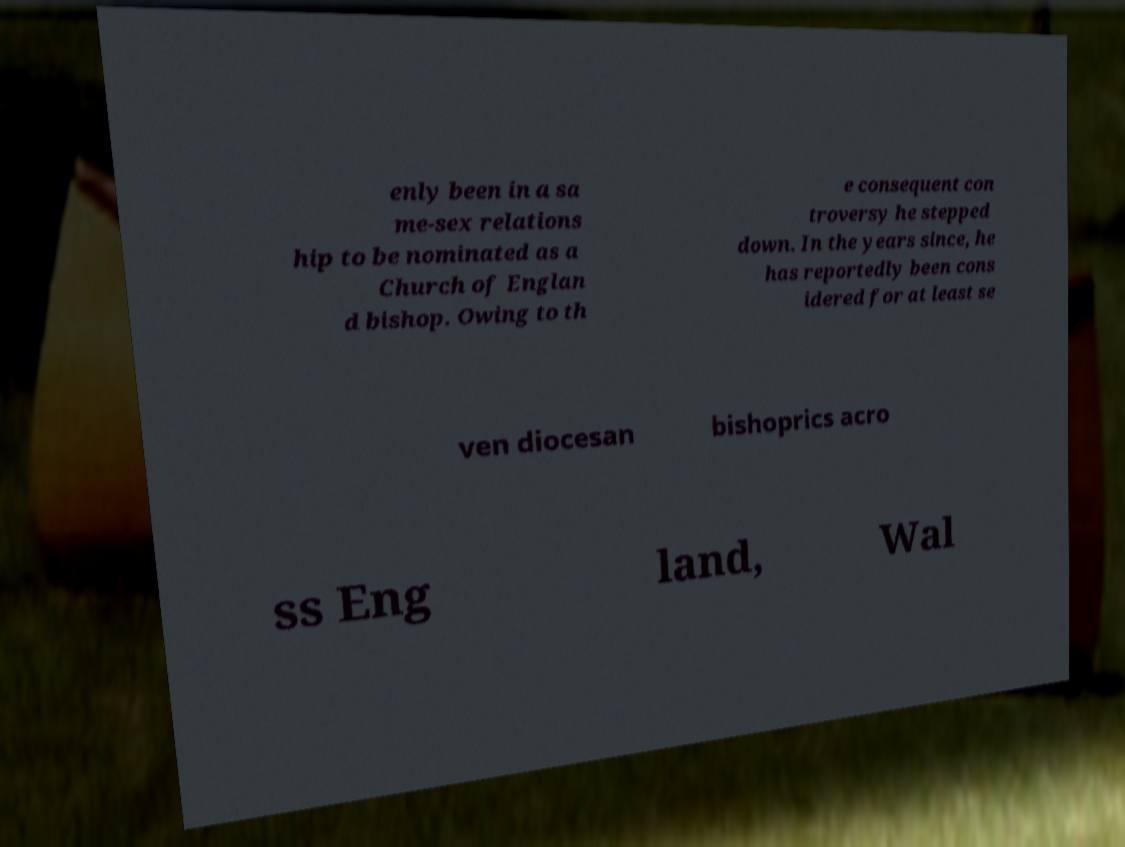Could you assist in decoding the text presented in this image and type it out clearly? enly been in a sa me-sex relations hip to be nominated as a Church of Englan d bishop. Owing to th e consequent con troversy he stepped down. In the years since, he has reportedly been cons idered for at least se ven diocesan bishoprics acro ss Eng land, Wal 